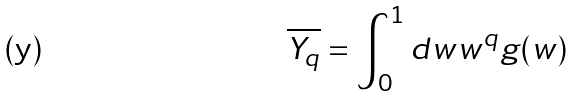Convert formula to latex. <formula><loc_0><loc_0><loc_500><loc_500>\overline { Y _ { q } } = \int _ { 0 } ^ { 1 } d w w ^ { q } g ( w )</formula> 